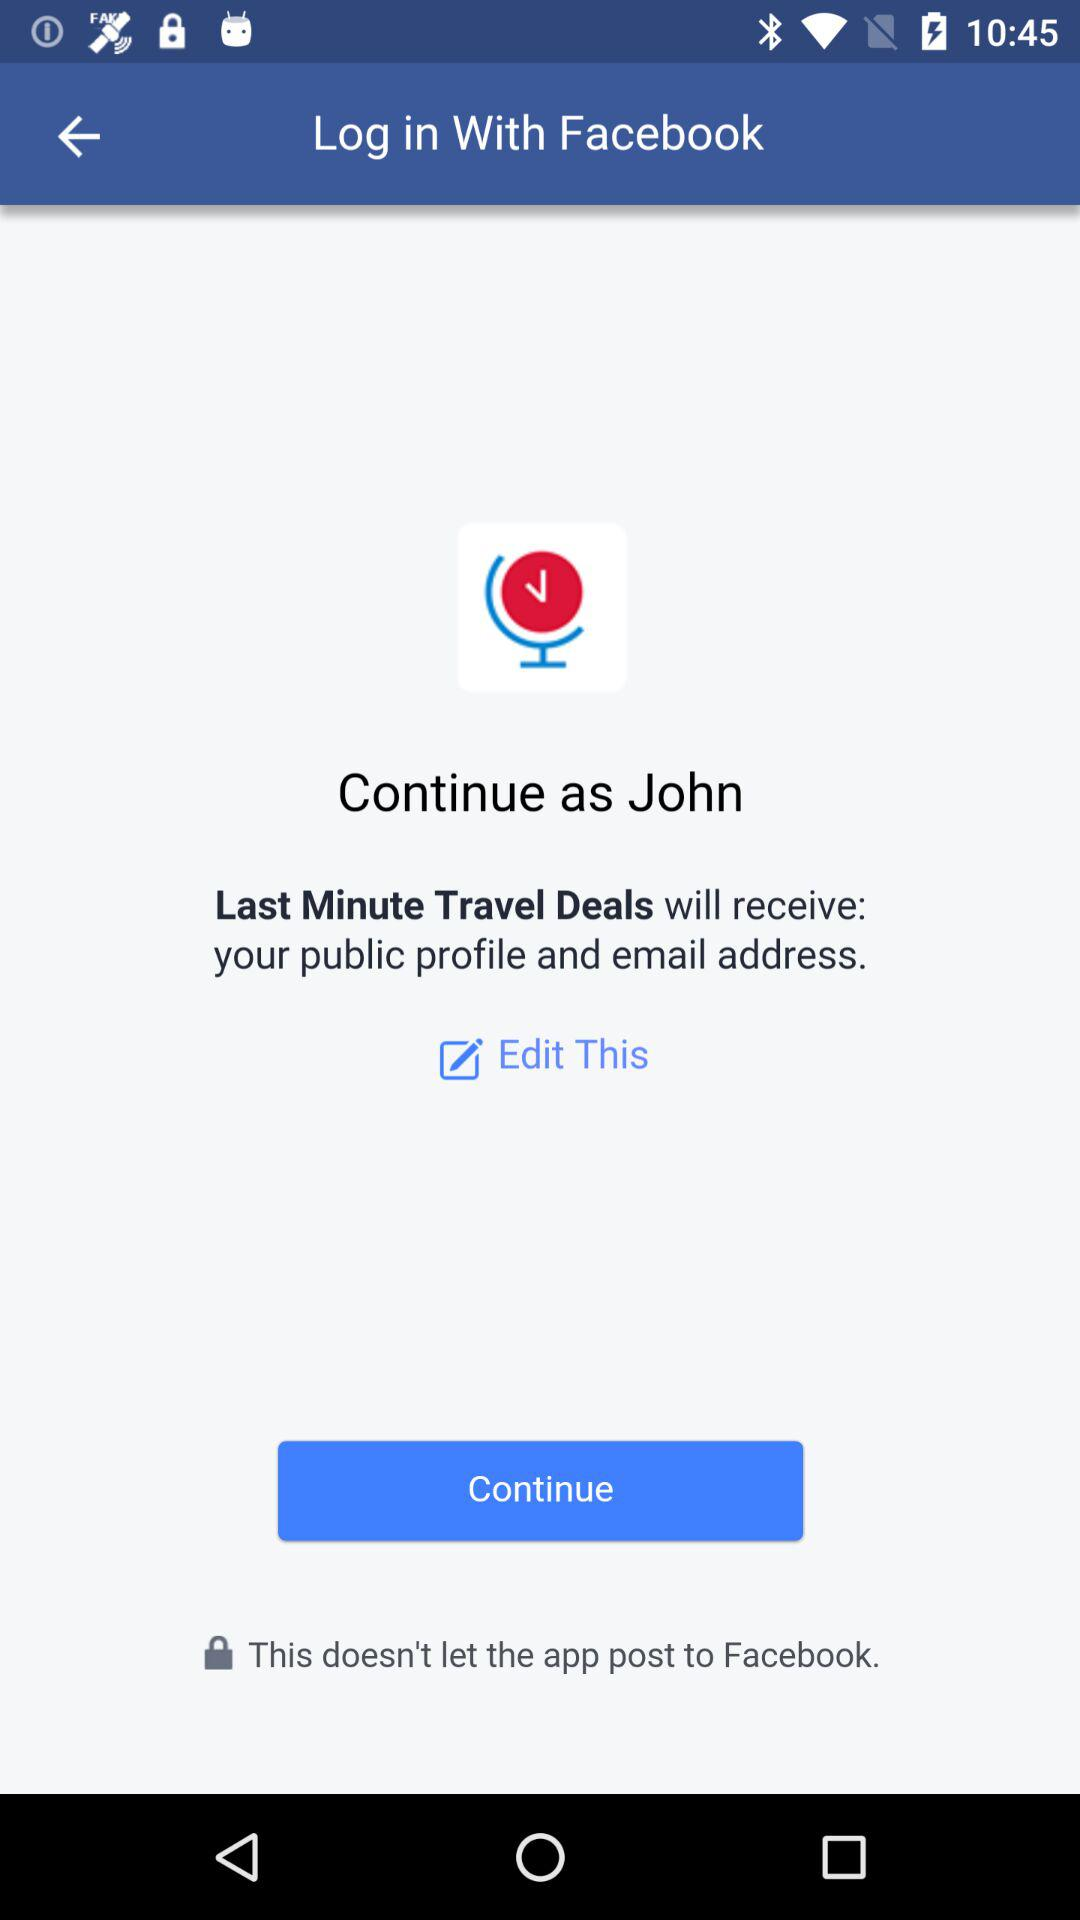What is the name of the user? The name of the user is John. 